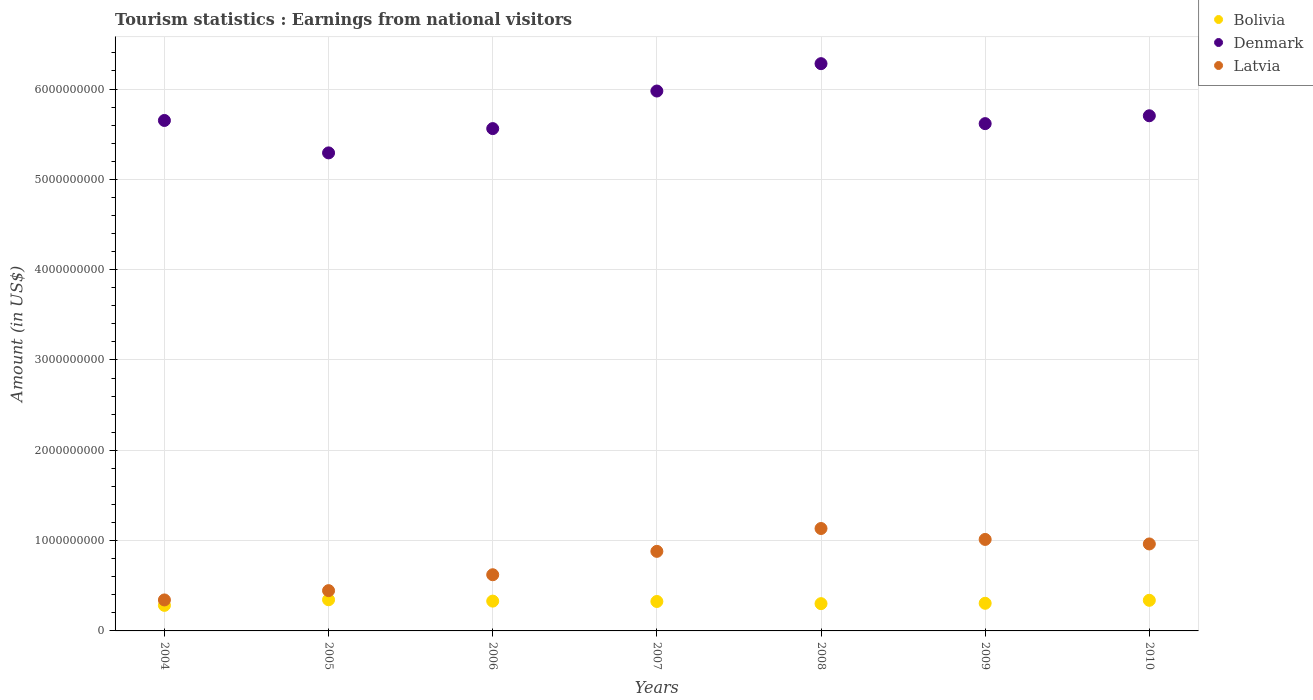What is the earnings from national visitors in Denmark in 2005?
Keep it short and to the point. 5.29e+09. Across all years, what is the maximum earnings from national visitors in Latvia?
Give a very brief answer. 1.13e+09. Across all years, what is the minimum earnings from national visitors in Bolivia?
Make the answer very short. 2.83e+08. In which year was the earnings from national visitors in Denmark minimum?
Offer a very short reply. 2005. What is the total earnings from national visitors in Bolivia in the graph?
Ensure brevity in your answer.  2.23e+09. What is the difference between the earnings from national visitors in Latvia in 2008 and that in 2010?
Give a very brief answer. 1.71e+08. What is the difference between the earnings from national visitors in Bolivia in 2010 and the earnings from national visitors in Denmark in 2009?
Give a very brief answer. -5.28e+09. What is the average earnings from national visitors in Denmark per year?
Provide a succinct answer. 5.73e+09. In the year 2005, what is the difference between the earnings from national visitors in Latvia and earnings from national visitors in Bolivia?
Your answer should be compact. 1.01e+08. In how many years, is the earnings from national visitors in Bolivia greater than 4800000000 US$?
Make the answer very short. 0. What is the ratio of the earnings from national visitors in Bolivia in 2005 to that in 2008?
Your answer should be compact. 1.14. Is the earnings from national visitors in Bolivia in 2004 less than that in 2006?
Make the answer very short. Yes. Is the difference between the earnings from national visitors in Latvia in 2006 and 2008 greater than the difference between the earnings from national visitors in Bolivia in 2006 and 2008?
Provide a short and direct response. No. What is the difference between the highest and the second highest earnings from national visitors in Bolivia?
Ensure brevity in your answer.  6.00e+06. What is the difference between the highest and the lowest earnings from national visitors in Bolivia?
Make the answer very short. 6.20e+07. In how many years, is the earnings from national visitors in Latvia greater than the average earnings from national visitors in Latvia taken over all years?
Keep it short and to the point. 4. Is the sum of the earnings from national visitors in Bolivia in 2004 and 2010 greater than the maximum earnings from national visitors in Latvia across all years?
Offer a very short reply. No. Is the earnings from national visitors in Bolivia strictly less than the earnings from national visitors in Latvia over the years?
Ensure brevity in your answer.  Yes. Are the values on the major ticks of Y-axis written in scientific E-notation?
Keep it short and to the point. No. How many legend labels are there?
Your answer should be very brief. 3. How are the legend labels stacked?
Give a very brief answer. Vertical. What is the title of the graph?
Give a very brief answer. Tourism statistics : Earnings from national visitors. Does "Malawi" appear as one of the legend labels in the graph?
Make the answer very short. No. What is the label or title of the X-axis?
Your answer should be very brief. Years. What is the label or title of the Y-axis?
Your answer should be very brief. Amount (in US$). What is the Amount (in US$) of Bolivia in 2004?
Your response must be concise. 2.83e+08. What is the Amount (in US$) in Denmark in 2004?
Ensure brevity in your answer.  5.65e+09. What is the Amount (in US$) in Latvia in 2004?
Your answer should be compact. 3.43e+08. What is the Amount (in US$) of Bolivia in 2005?
Your answer should be very brief. 3.45e+08. What is the Amount (in US$) of Denmark in 2005?
Ensure brevity in your answer.  5.29e+09. What is the Amount (in US$) of Latvia in 2005?
Offer a very short reply. 4.46e+08. What is the Amount (in US$) of Bolivia in 2006?
Give a very brief answer. 3.30e+08. What is the Amount (in US$) in Denmark in 2006?
Offer a very short reply. 5.56e+09. What is the Amount (in US$) in Latvia in 2006?
Provide a succinct answer. 6.22e+08. What is the Amount (in US$) of Bolivia in 2007?
Keep it short and to the point. 3.26e+08. What is the Amount (in US$) in Denmark in 2007?
Ensure brevity in your answer.  5.98e+09. What is the Amount (in US$) in Latvia in 2007?
Your answer should be compact. 8.81e+08. What is the Amount (in US$) in Bolivia in 2008?
Make the answer very short. 3.02e+08. What is the Amount (in US$) in Denmark in 2008?
Keep it short and to the point. 6.28e+09. What is the Amount (in US$) in Latvia in 2008?
Offer a very short reply. 1.13e+09. What is the Amount (in US$) of Bolivia in 2009?
Your answer should be compact. 3.06e+08. What is the Amount (in US$) in Denmark in 2009?
Your answer should be compact. 5.62e+09. What is the Amount (in US$) of Latvia in 2009?
Give a very brief answer. 1.01e+09. What is the Amount (in US$) of Bolivia in 2010?
Your answer should be compact. 3.39e+08. What is the Amount (in US$) in Denmark in 2010?
Keep it short and to the point. 5.70e+09. What is the Amount (in US$) in Latvia in 2010?
Provide a succinct answer. 9.63e+08. Across all years, what is the maximum Amount (in US$) in Bolivia?
Your response must be concise. 3.45e+08. Across all years, what is the maximum Amount (in US$) of Denmark?
Offer a terse response. 6.28e+09. Across all years, what is the maximum Amount (in US$) in Latvia?
Offer a very short reply. 1.13e+09. Across all years, what is the minimum Amount (in US$) of Bolivia?
Your answer should be very brief. 2.83e+08. Across all years, what is the minimum Amount (in US$) of Denmark?
Offer a terse response. 5.29e+09. Across all years, what is the minimum Amount (in US$) in Latvia?
Your answer should be compact. 3.43e+08. What is the total Amount (in US$) of Bolivia in the graph?
Ensure brevity in your answer.  2.23e+09. What is the total Amount (in US$) of Denmark in the graph?
Offer a very short reply. 4.01e+1. What is the total Amount (in US$) in Latvia in the graph?
Give a very brief answer. 5.40e+09. What is the difference between the Amount (in US$) of Bolivia in 2004 and that in 2005?
Give a very brief answer. -6.20e+07. What is the difference between the Amount (in US$) in Denmark in 2004 and that in 2005?
Your answer should be compact. 3.59e+08. What is the difference between the Amount (in US$) in Latvia in 2004 and that in 2005?
Offer a very short reply. -1.03e+08. What is the difference between the Amount (in US$) of Bolivia in 2004 and that in 2006?
Ensure brevity in your answer.  -4.70e+07. What is the difference between the Amount (in US$) of Denmark in 2004 and that in 2006?
Keep it short and to the point. 9.00e+07. What is the difference between the Amount (in US$) in Latvia in 2004 and that in 2006?
Your response must be concise. -2.79e+08. What is the difference between the Amount (in US$) in Bolivia in 2004 and that in 2007?
Give a very brief answer. -4.30e+07. What is the difference between the Amount (in US$) of Denmark in 2004 and that in 2007?
Your response must be concise. -3.26e+08. What is the difference between the Amount (in US$) in Latvia in 2004 and that in 2007?
Ensure brevity in your answer.  -5.38e+08. What is the difference between the Amount (in US$) of Bolivia in 2004 and that in 2008?
Your answer should be very brief. -1.90e+07. What is the difference between the Amount (in US$) of Denmark in 2004 and that in 2008?
Provide a succinct answer. -6.29e+08. What is the difference between the Amount (in US$) of Latvia in 2004 and that in 2008?
Offer a very short reply. -7.91e+08. What is the difference between the Amount (in US$) of Bolivia in 2004 and that in 2009?
Offer a terse response. -2.30e+07. What is the difference between the Amount (in US$) in Denmark in 2004 and that in 2009?
Keep it short and to the point. 3.50e+07. What is the difference between the Amount (in US$) in Latvia in 2004 and that in 2009?
Your answer should be compact. -6.70e+08. What is the difference between the Amount (in US$) in Bolivia in 2004 and that in 2010?
Your answer should be very brief. -5.60e+07. What is the difference between the Amount (in US$) in Denmark in 2004 and that in 2010?
Give a very brief answer. -5.20e+07. What is the difference between the Amount (in US$) of Latvia in 2004 and that in 2010?
Offer a very short reply. -6.20e+08. What is the difference between the Amount (in US$) of Bolivia in 2005 and that in 2006?
Keep it short and to the point. 1.50e+07. What is the difference between the Amount (in US$) in Denmark in 2005 and that in 2006?
Offer a very short reply. -2.69e+08. What is the difference between the Amount (in US$) in Latvia in 2005 and that in 2006?
Offer a terse response. -1.76e+08. What is the difference between the Amount (in US$) of Bolivia in 2005 and that in 2007?
Your answer should be compact. 1.90e+07. What is the difference between the Amount (in US$) in Denmark in 2005 and that in 2007?
Your answer should be compact. -6.85e+08. What is the difference between the Amount (in US$) in Latvia in 2005 and that in 2007?
Ensure brevity in your answer.  -4.35e+08. What is the difference between the Amount (in US$) in Bolivia in 2005 and that in 2008?
Provide a succinct answer. 4.30e+07. What is the difference between the Amount (in US$) in Denmark in 2005 and that in 2008?
Provide a succinct answer. -9.88e+08. What is the difference between the Amount (in US$) in Latvia in 2005 and that in 2008?
Your response must be concise. -6.88e+08. What is the difference between the Amount (in US$) of Bolivia in 2005 and that in 2009?
Give a very brief answer. 3.90e+07. What is the difference between the Amount (in US$) of Denmark in 2005 and that in 2009?
Your answer should be compact. -3.24e+08. What is the difference between the Amount (in US$) of Latvia in 2005 and that in 2009?
Your answer should be compact. -5.67e+08. What is the difference between the Amount (in US$) in Bolivia in 2005 and that in 2010?
Your response must be concise. 6.00e+06. What is the difference between the Amount (in US$) in Denmark in 2005 and that in 2010?
Your answer should be very brief. -4.11e+08. What is the difference between the Amount (in US$) of Latvia in 2005 and that in 2010?
Ensure brevity in your answer.  -5.17e+08. What is the difference between the Amount (in US$) in Denmark in 2006 and that in 2007?
Ensure brevity in your answer.  -4.16e+08. What is the difference between the Amount (in US$) of Latvia in 2006 and that in 2007?
Keep it short and to the point. -2.59e+08. What is the difference between the Amount (in US$) in Bolivia in 2006 and that in 2008?
Provide a short and direct response. 2.80e+07. What is the difference between the Amount (in US$) of Denmark in 2006 and that in 2008?
Your response must be concise. -7.19e+08. What is the difference between the Amount (in US$) in Latvia in 2006 and that in 2008?
Keep it short and to the point. -5.12e+08. What is the difference between the Amount (in US$) of Bolivia in 2006 and that in 2009?
Provide a short and direct response. 2.40e+07. What is the difference between the Amount (in US$) in Denmark in 2006 and that in 2009?
Offer a terse response. -5.50e+07. What is the difference between the Amount (in US$) of Latvia in 2006 and that in 2009?
Offer a terse response. -3.91e+08. What is the difference between the Amount (in US$) in Bolivia in 2006 and that in 2010?
Provide a short and direct response. -9.00e+06. What is the difference between the Amount (in US$) in Denmark in 2006 and that in 2010?
Keep it short and to the point. -1.42e+08. What is the difference between the Amount (in US$) of Latvia in 2006 and that in 2010?
Provide a short and direct response. -3.41e+08. What is the difference between the Amount (in US$) of Bolivia in 2007 and that in 2008?
Offer a terse response. 2.40e+07. What is the difference between the Amount (in US$) of Denmark in 2007 and that in 2008?
Make the answer very short. -3.03e+08. What is the difference between the Amount (in US$) in Latvia in 2007 and that in 2008?
Your answer should be very brief. -2.53e+08. What is the difference between the Amount (in US$) in Denmark in 2007 and that in 2009?
Offer a terse response. 3.61e+08. What is the difference between the Amount (in US$) of Latvia in 2007 and that in 2009?
Ensure brevity in your answer.  -1.32e+08. What is the difference between the Amount (in US$) of Bolivia in 2007 and that in 2010?
Offer a terse response. -1.30e+07. What is the difference between the Amount (in US$) of Denmark in 2007 and that in 2010?
Make the answer very short. 2.74e+08. What is the difference between the Amount (in US$) in Latvia in 2007 and that in 2010?
Offer a very short reply. -8.20e+07. What is the difference between the Amount (in US$) in Bolivia in 2008 and that in 2009?
Ensure brevity in your answer.  -4.00e+06. What is the difference between the Amount (in US$) in Denmark in 2008 and that in 2009?
Provide a short and direct response. 6.64e+08. What is the difference between the Amount (in US$) in Latvia in 2008 and that in 2009?
Offer a very short reply. 1.21e+08. What is the difference between the Amount (in US$) in Bolivia in 2008 and that in 2010?
Your answer should be compact. -3.70e+07. What is the difference between the Amount (in US$) in Denmark in 2008 and that in 2010?
Ensure brevity in your answer.  5.77e+08. What is the difference between the Amount (in US$) of Latvia in 2008 and that in 2010?
Offer a very short reply. 1.71e+08. What is the difference between the Amount (in US$) in Bolivia in 2009 and that in 2010?
Your answer should be compact. -3.30e+07. What is the difference between the Amount (in US$) of Denmark in 2009 and that in 2010?
Keep it short and to the point. -8.70e+07. What is the difference between the Amount (in US$) of Bolivia in 2004 and the Amount (in US$) of Denmark in 2005?
Make the answer very short. -5.01e+09. What is the difference between the Amount (in US$) in Bolivia in 2004 and the Amount (in US$) in Latvia in 2005?
Give a very brief answer. -1.63e+08. What is the difference between the Amount (in US$) of Denmark in 2004 and the Amount (in US$) of Latvia in 2005?
Make the answer very short. 5.21e+09. What is the difference between the Amount (in US$) in Bolivia in 2004 and the Amount (in US$) in Denmark in 2006?
Give a very brief answer. -5.28e+09. What is the difference between the Amount (in US$) in Bolivia in 2004 and the Amount (in US$) in Latvia in 2006?
Give a very brief answer. -3.39e+08. What is the difference between the Amount (in US$) of Denmark in 2004 and the Amount (in US$) of Latvia in 2006?
Your answer should be compact. 5.03e+09. What is the difference between the Amount (in US$) in Bolivia in 2004 and the Amount (in US$) in Denmark in 2007?
Your response must be concise. -5.70e+09. What is the difference between the Amount (in US$) in Bolivia in 2004 and the Amount (in US$) in Latvia in 2007?
Provide a short and direct response. -5.98e+08. What is the difference between the Amount (in US$) of Denmark in 2004 and the Amount (in US$) of Latvia in 2007?
Your answer should be compact. 4.77e+09. What is the difference between the Amount (in US$) in Bolivia in 2004 and the Amount (in US$) in Denmark in 2008?
Make the answer very short. -6.00e+09. What is the difference between the Amount (in US$) in Bolivia in 2004 and the Amount (in US$) in Latvia in 2008?
Give a very brief answer. -8.51e+08. What is the difference between the Amount (in US$) of Denmark in 2004 and the Amount (in US$) of Latvia in 2008?
Provide a short and direct response. 4.52e+09. What is the difference between the Amount (in US$) of Bolivia in 2004 and the Amount (in US$) of Denmark in 2009?
Keep it short and to the point. -5.33e+09. What is the difference between the Amount (in US$) of Bolivia in 2004 and the Amount (in US$) of Latvia in 2009?
Make the answer very short. -7.30e+08. What is the difference between the Amount (in US$) of Denmark in 2004 and the Amount (in US$) of Latvia in 2009?
Offer a very short reply. 4.64e+09. What is the difference between the Amount (in US$) in Bolivia in 2004 and the Amount (in US$) in Denmark in 2010?
Make the answer very short. -5.42e+09. What is the difference between the Amount (in US$) of Bolivia in 2004 and the Amount (in US$) of Latvia in 2010?
Provide a short and direct response. -6.80e+08. What is the difference between the Amount (in US$) in Denmark in 2004 and the Amount (in US$) in Latvia in 2010?
Your answer should be compact. 4.69e+09. What is the difference between the Amount (in US$) in Bolivia in 2005 and the Amount (in US$) in Denmark in 2006?
Your answer should be very brief. -5.22e+09. What is the difference between the Amount (in US$) of Bolivia in 2005 and the Amount (in US$) of Latvia in 2006?
Offer a very short reply. -2.77e+08. What is the difference between the Amount (in US$) in Denmark in 2005 and the Amount (in US$) in Latvia in 2006?
Provide a short and direct response. 4.67e+09. What is the difference between the Amount (in US$) of Bolivia in 2005 and the Amount (in US$) of Denmark in 2007?
Provide a short and direct response. -5.63e+09. What is the difference between the Amount (in US$) in Bolivia in 2005 and the Amount (in US$) in Latvia in 2007?
Provide a short and direct response. -5.36e+08. What is the difference between the Amount (in US$) in Denmark in 2005 and the Amount (in US$) in Latvia in 2007?
Keep it short and to the point. 4.41e+09. What is the difference between the Amount (in US$) in Bolivia in 2005 and the Amount (in US$) in Denmark in 2008?
Make the answer very short. -5.94e+09. What is the difference between the Amount (in US$) of Bolivia in 2005 and the Amount (in US$) of Latvia in 2008?
Provide a short and direct response. -7.89e+08. What is the difference between the Amount (in US$) of Denmark in 2005 and the Amount (in US$) of Latvia in 2008?
Your answer should be very brief. 4.16e+09. What is the difference between the Amount (in US$) in Bolivia in 2005 and the Amount (in US$) in Denmark in 2009?
Your answer should be very brief. -5.27e+09. What is the difference between the Amount (in US$) in Bolivia in 2005 and the Amount (in US$) in Latvia in 2009?
Give a very brief answer. -6.68e+08. What is the difference between the Amount (in US$) of Denmark in 2005 and the Amount (in US$) of Latvia in 2009?
Give a very brief answer. 4.28e+09. What is the difference between the Amount (in US$) in Bolivia in 2005 and the Amount (in US$) in Denmark in 2010?
Keep it short and to the point. -5.36e+09. What is the difference between the Amount (in US$) of Bolivia in 2005 and the Amount (in US$) of Latvia in 2010?
Give a very brief answer. -6.18e+08. What is the difference between the Amount (in US$) of Denmark in 2005 and the Amount (in US$) of Latvia in 2010?
Your response must be concise. 4.33e+09. What is the difference between the Amount (in US$) of Bolivia in 2006 and the Amount (in US$) of Denmark in 2007?
Your answer should be very brief. -5.65e+09. What is the difference between the Amount (in US$) in Bolivia in 2006 and the Amount (in US$) in Latvia in 2007?
Keep it short and to the point. -5.51e+08. What is the difference between the Amount (in US$) of Denmark in 2006 and the Amount (in US$) of Latvia in 2007?
Offer a terse response. 4.68e+09. What is the difference between the Amount (in US$) of Bolivia in 2006 and the Amount (in US$) of Denmark in 2008?
Your answer should be compact. -5.95e+09. What is the difference between the Amount (in US$) in Bolivia in 2006 and the Amount (in US$) in Latvia in 2008?
Ensure brevity in your answer.  -8.04e+08. What is the difference between the Amount (in US$) of Denmark in 2006 and the Amount (in US$) of Latvia in 2008?
Make the answer very short. 4.43e+09. What is the difference between the Amount (in US$) in Bolivia in 2006 and the Amount (in US$) in Denmark in 2009?
Provide a succinct answer. -5.29e+09. What is the difference between the Amount (in US$) of Bolivia in 2006 and the Amount (in US$) of Latvia in 2009?
Provide a succinct answer. -6.83e+08. What is the difference between the Amount (in US$) in Denmark in 2006 and the Amount (in US$) in Latvia in 2009?
Your answer should be compact. 4.55e+09. What is the difference between the Amount (in US$) of Bolivia in 2006 and the Amount (in US$) of Denmark in 2010?
Your response must be concise. -5.37e+09. What is the difference between the Amount (in US$) in Bolivia in 2006 and the Amount (in US$) in Latvia in 2010?
Provide a short and direct response. -6.33e+08. What is the difference between the Amount (in US$) in Denmark in 2006 and the Amount (in US$) in Latvia in 2010?
Ensure brevity in your answer.  4.60e+09. What is the difference between the Amount (in US$) in Bolivia in 2007 and the Amount (in US$) in Denmark in 2008?
Your response must be concise. -5.96e+09. What is the difference between the Amount (in US$) in Bolivia in 2007 and the Amount (in US$) in Latvia in 2008?
Your answer should be very brief. -8.08e+08. What is the difference between the Amount (in US$) in Denmark in 2007 and the Amount (in US$) in Latvia in 2008?
Your answer should be compact. 4.84e+09. What is the difference between the Amount (in US$) of Bolivia in 2007 and the Amount (in US$) of Denmark in 2009?
Your answer should be compact. -5.29e+09. What is the difference between the Amount (in US$) of Bolivia in 2007 and the Amount (in US$) of Latvia in 2009?
Your response must be concise. -6.87e+08. What is the difference between the Amount (in US$) in Denmark in 2007 and the Amount (in US$) in Latvia in 2009?
Your response must be concise. 4.96e+09. What is the difference between the Amount (in US$) in Bolivia in 2007 and the Amount (in US$) in Denmark in 2010?
Your answer should be compact. -5.38e+09. What is the difference between the Amount (in US$) in Bolivia in 2007 and the Amount (in US$) in Latvia in 2010?
Ensure brevity in your answer.  -6.37e+08. What is the difference between the Amount (in US$) of Denmark in 2007 and the Amount (in US$) of Latvia in 2010?
Offer a terse response. 5.02e+09. What is the difference between the Amount (in US$) of Bolivia in 2008 and the Amount (in US$) of Denmark in 2009?
Offer a very short reply. -5.32e+09. What is the difference between the Amount (in US$) of Bolivia in 2008 and the Amount (in US$) of Latvia in 2009?
Provide a short and direct response. -7.11e+08. What is the difference between the Amount (in US$) of Denmark in 2008 and the Amount (in US$) of Latvia in 2009?
Your answer should be very brief. 5.27e+09. What is the difference between the Amount (in US$) in Bolivia in 2008 and the Amount (in US$) in Denmark in 2010?
Your answer should be compact. -5.40e+09. What is the difference between the Amount (in US$) in Bolivia in 2008 and the Amount (in US$) in Latvia in 2010?
Provide a succinct answer. -6.61e+08. What is the difference between the Amount (in US$) of Denmark in 2008 and the Amount (in US$) of Latvia in 2010?
Your response must be concise. 5.32e+09. What is the difference between the Amount (in US$) of Bolivia in 2009 and the Amount (in US$) of Denmark in 2010?
Make the answer very short. -5.40e+09. What is the difference between the Amount (in US$) of Bolivia in 2009 and the Amount (in US$) of Latvia in 2010?
Keep it short and to the point. -6.57e+08. What is the difference between the Amount (in US$) of Denmark in 2009 and the Amount (in US$) of Latvia in 2010?
Your answer should be very brief. 4.65e+09. What is the average Amount (in US$) in Bolivia per year?
Your response must be concise. 3.19e+08. What is the average Amount (in US$) of Denmark per year?
Offer a very short reply. 5.73e+09. What is the average Amount (in US$) of Latvia per year?
Your response must be concise. 7.72e+08. In the year 2004, what is the difference between the Amount (in US$) of Bolivia and Amount (in US$) of Denmark?
Provide a succinct answer. -5.37e+09. In the year 2004, what is the difference between the Amount (in US$) in Bolivia and Amount (in US$) in Latvia?
Provide a succinct answer. -6.00e+07. In the year 2004, what is the difference between the Amount (in US$) in Denmark and Amount (in US$) in Latvia?
Provide a succinct answer. 5.31e+09. In the year 2005, what is the difference between the Amount (in US$) in Bolivia and Amount (in US$) in Denmark?
Give a very brief answer. -4.95e+09. In the year 2005, what is the difference between the Amount (in US$) of Bolivia and Amount (in US$) of Latvia?
Your response must be concise. -1.01e+08. In the year 2005, what is the difference between the Amount (in US$) of Denmark and Amount (in US$) of Latvia?
Your response must be concise. 4.85e+09. In the year 2006, what is the difference between the Amount (in US$) in Bolivia and Amount (in US$) in Denmark?
Keep it short and to the point. -5.23e+09. In the year 2006, what is the difference between the Amount (in US$) in Bolivia and Amount (in US$) in Latvia?
Offer a very short reply. -2.92e+08. In the year 2006, what is the difference between the Amount (in US$) in Denmark and Amount (in US$) in Latvia?
Your response must be concise. 4.94e+09. In the year 2007, what is the difference between the Amount (in US$) in Bolivia and Amount (in US$) in Denmark?
Ensure brevity in your answer.  -5.65e+09. In the year 2007, what is the difference between the Amount (in US$) in Bolivia and Amount (in US$) in Latvia?
Provide a succinct answer. -5.55e+08. In the year 2007, what is the difference between the Amount (in US$) of Denmark and Amount (in US$) of Latvia?
Provide a short and direct response. 5.10e+09. In the year 2008, what is the difference between the Amount (in US$) in Bolivia and Amount (in US$) in Denmark?
Offer a terse response. -5.98e+09. In the year 2008, what is the difference between the Amount (in US$) in Bolivia and Amount (in US$) in Latvia?
Keep it short and to the point. -8.32e+08. In the year 2008, what is the difference between the Amount (in US$) in Denmark and Amount (in US$) in Latvia?
Give a very brief answer. 5.15e+09. In the year 2009, what is the difference between the Amount (in US$) in Bolivia and Amount (in US$) in Denmark?
Make the answer very short. -5.31e+09. In the year 2009, what is the difference between the Amount (in US$) in Bolivia and Amount (in US$) in Latvia?
Your response must be concise. -7.07e+08. In the year 2009, what is the difference between the Amount (in US$) in Denmark and Amount (in US$) in Latvia?
Provide a short and direct response. 4.60e+09. In the year 2010, what is the difference between the Amount (in US$) in Bolivia and Amount (in US$) in Denmark?
Provide a short and direct response. -5.36e+09. In the year 2010, what is the difference between the Amount (in US$) in Bolivia and Amount (in US$) in Latvia?
Your response must be concise. -6.24e+08. In the year 2010, what is the difference between the Amount (in US$) of Denmark and Amount (in US$) of Latvia?
Provide a short and direct response. 4.74e+09. What is the ratio of the Amount (in US$) of Bolivia in 2004 to that in 2005?
Keep it short and to the point. 0.82. What is the ratio of the Amount (in US$) of Denmark in 2004 to that in 2005?
Provide a short and direct response. 1.07. What is the ratio of the Amount (in US$) in Latvia in 2004 to that in 2005?
Provide a succinct answer. 0.77. What is the ratio of the Amount (in US$) in Bolivia in 2004 to that in 2006?
Your response must be concise. 0.86. What is the ratio of the Amount (in US$) in Denmark in 2004 to that in 2006?
Your answer should be compact. 1.02. What is the ratio of the Amount (in US$) of Latvia in 2004 to that in 2006?
Offer a very short reply. 0.55. What is the ratio of the Amount (in US$) of Bolivia in 2004 to that in 2007?
Your response must be concise. 0.87. What is the ratio of the Amount (in US$) of Denmark in 2004 to that in 2007?
Your answer should be very brief. 0.95. What is the ratio of the Amount (in US$) in Latvia in 2004 to that in 2007?
Your response must be concise. 0.39. What is the ratio of the Amount (in US$) in Bolivia in 2004 to that in 2008?
Ensure brevity in your answer.  0.94. What is the ratio of the Amount (in US$) in Denmark in 2004 to that in 2008?
Give a very brief answer. 0.9. What is the ratio of the Amount (in US$) in Latvia in 2004 to that in 2008?
Your answer should be very brief. 0.3. What is the ratio of the Amount (in US$) in Bolivia in 2004 to that in 2009?
Give a very brief answer. 0.92. What is the ratio of the Amount (in US$) in Denmark in 2004 to that in 2009?
Offer a terse response. 1.01. What is the ratio of the Amount (in US$) in Latvia in 2004 to that in 2009?
Ensure brevity in your answer.  0.34. What is the ratio of the Amount (in US$) of Bolivia in 2004 to that in 2010?
Your answer should be very brief. 0.83. What is the ratio of the Amount (in US$) of Denmark in 2004 to that in 2010?
Keep it short and to the point. 0.99. What is the ratio of the Amount (in US$) of Latvia in 2004 to that in 2010?
Give a very brief answer. 0.36. What is the ratio of the Amount (in US$) in Bolivia in 2005 to that in 2006?
Offer a terse response. 1.05. What is the ratio of the Amount (in US$) in Denmark in 2005 to that in 2006?
Offer a terse response. 0.95. What is the ratio of the Amount (in US$) in Latvia in 2005 to that in 2006?
Give a very brief answer. 0.72. What is the ratio of the Amount (in US$) of Bolivia in 2005 to that in 2007?
Your response must be concise. 1.06. What is the ratio of the Amount (in US$) in Denmark in 2005 to that in 2007?
Your answer should be compact. 0.89. What is the ratio of the Amount (in US$) in Latvia in 2005 to that in 2007?
Provide a succinct answer. 0.51. What is the ratio of the Amount (in US$) of Bolivia in 2005 to that in 2008?
Keep it short and to the point. 1.14. What is the ratio of the Amount (in US$) in Denmark in 2005 to that in 2008?
Provide a short and direct response. 0.84. What is the ratio of the Amount (in US$) in Latvia in 2005 to that in 2008?
Ensure brevity in your answer.  0.39. What is the ratio of the Amount (in US$) of Bolivia in 2005 to that in 2009?
Offer a very short reply. 1.13. What is the ratio of the Amount (in US$) in Denmark in 2005 to that in 2009?
Your answer should be very brief. 0.94. What is the ratio of the Amount (in US$) in Latvia in 2005 to that in 2009?
Your answer should be very brief. 0.44. What is the ratio of the Amount (in US$) of Bolivia in 2005 to that in 2010?
Give a very brief answer. 1.02. What is the ratio of the Amount (in US$) in Denmark in 2005 to that in 2010?
Your response must be concise. 0.93. What is the ratio of the Amount (in US$) of Latvia in 2005 to that in 2010?
Your answer should be compact. 0.46. What is the ratio of the Amount (in US$) in Bolivia in 2006 to that in 2007?
Make the answer very short. 1.01. What is the ratio of the Amount (in US$) in Denmark in 2006 to that in 2007?
Keep it short and to the point. 0.93. What is the ratio of the Amount (in US$) of Latvia in 2006 to that in 2007?
Keep it short and to the point. 0.71. What is the ratio of the Amount (in US$) of Bolivia in 2006 to that in 2008?
Keep it short and to the point. 1.09. What is the ratio of the Amount (in US$) of Denmark in 2006 to that in 2008?
Provide a short and direct response. 0.89. What is the ratio of the Amount (in US$) of Latvia in 2006 to that in 2008?
Give a very brief answer. 0.55. What is the ratio of the Amount (in US$) in Bolivia in 2006 to that in 2009?
Your answer should be very brief. 1.08. What is the ratio of the Amount (in US$) in Denmark in 2006 to that in 2009?
Give a very brief answer. 0.99. What is the ratio of the Amount (in US$) of Latvia in 2006 to that in 2009?
Your response must be concise. 0.61. What is the ratio of the Amount (in US$) in Bolivia in 2006 to that in 2010?
Give a very brief answer. 0.97. What is the ratio of the Amount (in US$) of Denmark in 2006 to that in 2010?
Make the answer very short. 0.98. What is the ratio of the Amount (in US$) in Latvia in 2006 to that in 2010?
Provide a short and direct response. 0.65. What is the ratio of the Amount (in US$) of Bolivia in 2007 to that in 2008?
Provide a succinct answer. 1.08. What is the ratio of the Amount (in US$) in Denmark in 2007 to that in 2008?
Ensure brevity in your answer.  0.95. What is the ratio of the Amount (in US$) in Latvia in 2007 to that in 2008?
Your answer should be very brief. 0.78. What is the ratio of the Amount (in US$) in Bolivia in 2007 to that in 2009?
Provide a short and direct response. 1.07. What is the ratio of the Amount (in US$) in Denmark in 2007 to that in 2009?
Your answer should be very brief. 1.06. What is the ratio of the Amount (in US$) in Latvia in 2007 to that in 2009?
Give a very brief answer. 0.87. What is the ratio of the Amount (in US$) in Bolivia in 2007 to that in 2010?
Your response must be concise. 0.96. What is the ratio of the Amount (in US$) in Denmark in 2007 to that in 2010?
Give a very brief answer. 1.05. What is the ratio of the Amount (in US$) of Latvia in 2007 to that in 2010?
Provide a short and direct response. 0.91. What is the ratio of the Amount (in US$) in Bolivia in 2008 to that in 2009?
Your answer should be very brief. 0.99. What is the ratio of the Amount (in US$) of Denmark in 2008 to that in 2009?
Ensure brevity in your answer.  1.12. What is the ratio of the Amount (in US$) in Latvia in 2008 to that in 2009?
Offer a terse response. 1.12. What is the ratio of the Amount (in US$) in Bolivia in 2008 to that in 2010?
Your response must be concise. 0.89. What is the ratio of the Amount (in US$) of Denmark in 2008 to that in 2010?
Ensure brevity in your answer.  1.1. What is the ratio of the Amount (in US$) in Latvia in 2008 to that in 2010?
Your answer should be very brief. 1.18. What is the ratio of the Amount (in US$) of Bolivia in 2009 to that in 2010?
Ensure brevity in your answer.  0.9. What is the ratio of the Amount (in US$) of Denmark in 2009 to that in 2010?
Your answer should be very brief. 0.98. What is the ratio of the Amount (in US$) of Latvia in 2009 to that in 2010?
Keep it short and to the point. 1.05. What is the difference between the highest and the second highest Amount (in US$) of Bolivia?
Your answer should be very brief. 6.00e+06. What is the difference between the highest and the second highest Amount (in US$) in Denmark?
Offer a very short reply. 3.03e+08. What is the difference between the highest and the second highest Amount (in US$) of Latvia?
Ensure brevity in your answer.  1.21e+08. What is the difference between the highest and the lowest Amount (in US$) in Bolivia?
Provide a succinct answer. 6.20e+07. What is the difference between the highest and the lowest Amount (in US$) in Denmark?
Provide a short and direct response. 9.88e+08. What is the difference between the highest and the lowest Amount (in US$) of Latvia?
Keep it short and to the point. 7.91e+08. 